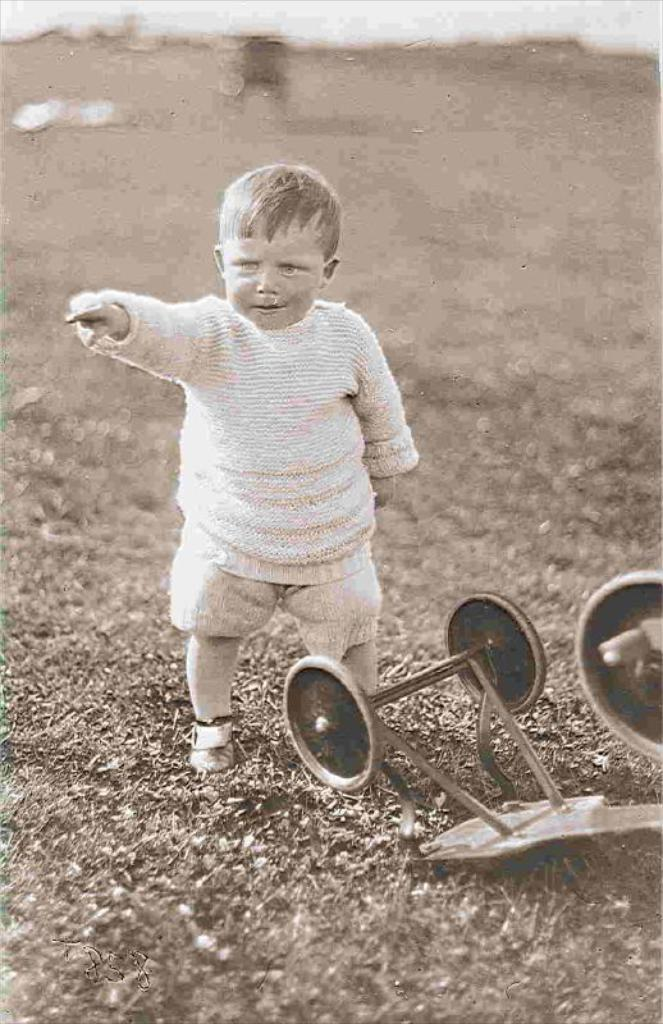What is the main subject of the image? The main subject of the image is a kid standing. What else can be seen in the image besides the kid? There is a vehicle on the grass in the image. Can you describe the background of the image? The background of the image is blurry. What type of joke is being told by the wire in the image? There is no wire present in the image, and therefore no joke can be told by it. 